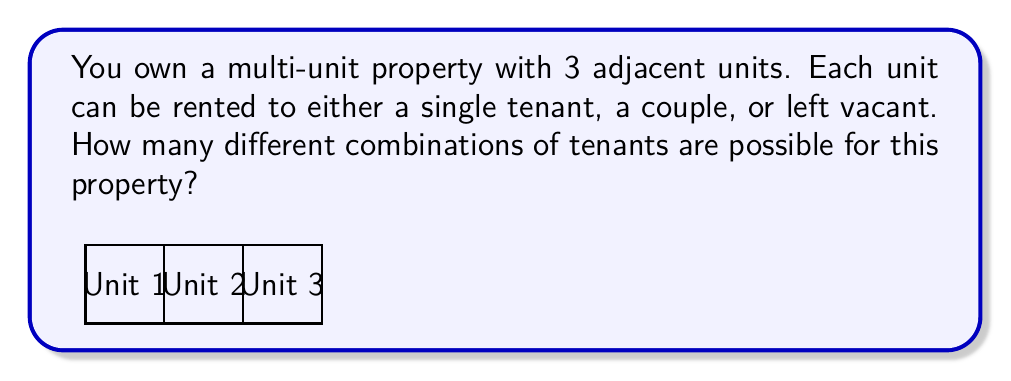Provide a solution to this math problem. Let's approach this step-by-step:

1) For each unit, we have 3 options:
   - Single tenant
   - Couple
   - Vacant

2) This means for each unit, we have 3 choices.

3) We need to make this choice for all 3 units independently.

4) This is a perfect scenario for applying the multiplication principle of counting.

5) The multiplication principle states that if we have $m$ ways of doing something and $n$ ways of doing another thing, then there are $m \times n$ ways of doing both things.

6) In our case, we have 3 choices for each of the 3 units.

7) Therefore, the total number of combinations is:

   $$ 3 \times 3 \times 3 = 3^3 = 27 $$

Thus, there are 27 different possible combinations of tenants for this property.
Answer: $27$ 